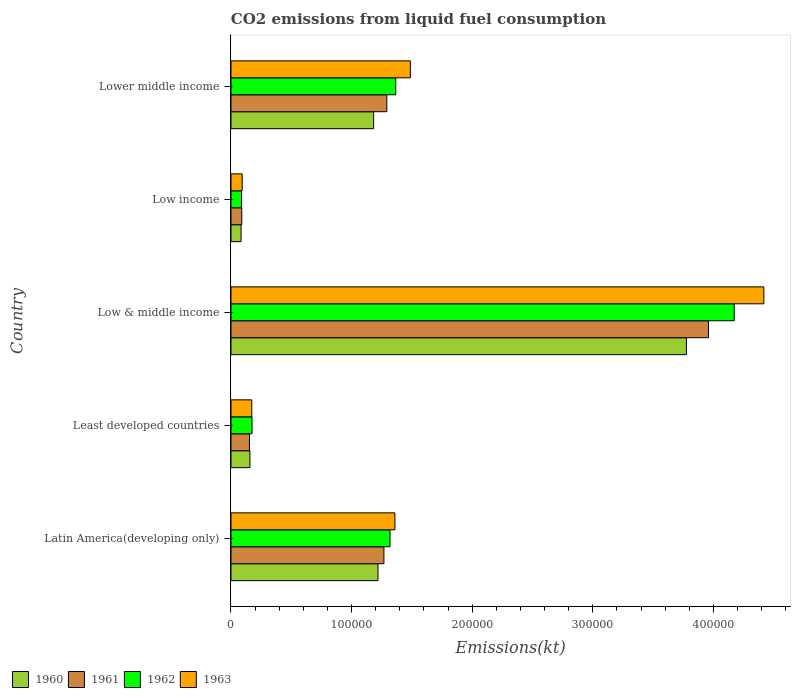How many different coloured bars are there?
Ensure brevity in your answer.  4. How many groups of bars are there?
Give a very brief answer. 5. How many bars are there on the 1st tick from the top?
Make the answer very short. 4. What is the label of the 5th group of bars from the top?
Your response must be concise. Latin America(developing only). What is the amount of CO2 emitted in 1960 in Low income?
Offer a terse response. 8381.5. Across all countries, what is the maximum amount of CO2 emitted in 1962?
Provide a succinct answer. 4.17e+05. Across all countries, what is the minimum amount of CO2 emitted in 1962?
Offer a terse response. 8722.53. In which country was the amount of CO2 emitted in 1960 maximum?
Your response must be concise. Low & middle income. In which country was the amount of CO2 emitted in 1963 minimum?
Offer a very short reply. Low income. What is the total amount of CO2 emitted in 1963 in the graph?
Provide a short and direct response. 7.53e+05. What is the difference between the amount of CO2 emitted in 1960 in Least developed countries and that in Lower middle income?
Ensure brevity in your answer.  -1.03e+05. What is the difference between the amount of CO2 emitted in 1962 in Lower middle income and the amount of CO2 emitted in 1963 in Low & middle income?
Offer a terse response. -3.05e+05. What is the average amount of CO2 emitted in 1961 per country?
Ensure brevity in your answer.  1.35e+05. What is the difference between the amount of CO2 emitted in 1963 and amount of CO2 emitted in 1962 in Low income?
Keep it short and to the point. 558.28. In how many countries, is the amount of CO2 emitted in 1962 greater than 180000 kt?
Ensure brevity in your answer.  1. What is the ratio of the amount of CO2 emitted in 1960 in Low income to that in Lower middle income?
Keep it short and to the point. 0.07. Is the amount of CO2 emitted in 1961 in Latin America(developing only) less than that in Lower middle income?
Make the answer very short. Yes. Is the difference between the amount of CO2 emitted in 1963 in Low & middle income and Lower middle income greater than the difference between the amount of CO2 emitted in 1962 in Low & middle income and Lower middle income?
Provide a short and direct response. Yes. What is the difference between the highest and the second highest amount of CO2 emitted in 1963?
Provide a succinct answer. 2.93e+05. What is the difference between the highest and the lowest amount of CO2 emitted in 1961?
Make the answer very short. 3.87e+05. In how many countries, is the amount of CO2 emitted in 1962 greater than the average amount of CO2 emitted in 1962 taken over all countries?
Your answer should be compact. 1. Is it the case that in every country, the sum of the amount of CO2 emitted in 1961 and amount of CO2 emitted in 1963 is greater than the sum of amount of CO2 emitted in 1962 and amount of CO2 emitted in 1960?
Offer a terse response. No. What does the 1st bar from the bottom in Lower middle income represents?
Give a very brief answer. 1960. Is it the case that in every country, the sum of the amount of CO2 emitted in 1961 and amount of CO2 emitted in 1962 is greater than the amount of CO2 emitted in 1963?
Provide a short and direct response. Yes. Are all the bars in the graph horizontal?
Your answer should be compact. Yes. Does the graph contain any zero values?
Make the answer very short. No. Does the graph contain grids?
Ensure brevity in your answer.  No. How are the legend labels stacked?
Provide a succinct answer. Horizontal. What is the title of the graph?
Your response must be concise. CO2 emissions from liquid fuel consumption. Does "1972" appear as one of the legend labels in the graph?
Keep it short and to the point. No. What is the label or title of the X-axis?
Give a very brief answer. Emissions(kt). What is the Emissions(kt) of 1960 in Latin America(developing only)?
Provide a short and direct response. 1.22e+05. What is the Emissions(kt) of 1961 in Latin America(developing only)?
Offer a very short reply. 1.27e+05. What is the Emissions(kt) of 1962 in Latin America(developing only)?
Ensure brevity in your answer.  1.32e+05. What is the Emissions(kt) in 1963 in Latin America(developing only)?
Your answer should be very brief. 1.36e+05. What is the Emissions(kt) of 1960 in Least developed countries?
Your response must be concise. 1.57e+04. What is the Emissions(kt) in 1961 in Least developed countries?
Keep it short and to the point. 1.53e+04. What is the Emissions(kt) in 1962 in Least developed countries?
Offer a terse response. 1.75e+04. What is the Emissions(kt) in 1963 in Least developed countries?
Give a very brief answer. 1.73e+04. What is the Emissions(kt) of 1960 in Low & middle income?
Offer a terse response. 3.78e+05. What is the Emissions(kt) of 1961 in Low & middle income?
Keep it short and to the point. 3.96e+05. What is the Emissions(kt) of 1962 in Low & middle income?
Keep it short and to the point. 4.17e+05. What is the Emissions(kt) in 1963 in Low & middle income?
Offer a terse response. 4.42e+05. What is the Emissions(kt) in 1960 in Low income?
Provide a short and direct response. 8381.5. What is the Emissions(kt) of 1961 in Low income?
Offer a terse response. 8977.1. What is the Emissions(kt) in 1962 in Low income?
Your answer should be very brief. 8722.53. What is the Emissions(kt) of 1963 in Low income?
Offer a very short reply. 9280.81. What is the Emissions(kt) in 1960 in Lower middle income?
Provide a short and direct response. 1.18e+05. What is the Emissions(kt) of 1961 in Lower middle income?
Your answer should be compact. 1.29e+05. What is the Emissions(kt) in 1962 in Lower middle income?
Your answer should be very brief. 1.37e+05. What is the Emissions(kt) of 1963 in Lower middle income?
Provide a succinct answer. 1.49e+05. Across all countries, what is the maximum Emissions(kt) of 1960?
Offer a very short reply. 3.78e+05. Across all countries, what is the maximum Emissions(kt) of 1961?
Provide a short and direct response. 3.96e+05. Across all countries, what is the maximum Emissions(kt) of 1962?
Make the answer very short. 4.17e+05. Across all countries, what is the maximum Emissions(kt) of 1963?
Give a very brief answer. 4.42e+05. Across all countries, what is the minimum Emissions(kt) of 1960?
Provide a short and direct response. 8381.5. Across all countries, what is the minimum Emissions(kt) in 1961?
Offer a terse response. 8977.1. Across all countries, what is the minimum Emissions(kt) of 1962?
Make the answer very short. 8722.53. Across all countries, what is the minimum Emissions(kt) of 1963?
Ensure brevity in your answer.  9280.81. What is the total Emissions(kt) of 1960 in the graph?
Give a very brief answer. 6.42e+05. What is the total Emissions(kt) of 1961 in the graph?
Offer a terse response. 6.76e+05. What is the total Emissions(kt) of 1962 in the graph?
Provide a succinct answer. 7.12e+05. What is the total Emissions(kt) in 1963 in the graph?
Your answer should be very brief. 7.53e+05. What is the difference between the Emissions(kt) in 1960 in Latin America(developing only) and that in Least developed countries?
Your answer should be very brief. 1.06e+05. What is the difference between the Emissions(kt) of 1961 in Latin America(developing only) and that in Least developed countries?
Ensure brevity in your answer.  1.11e+05. What is the difference between the Emissions(kt) in 1962 in Latin America(developing only) and that in Least developed countries?
Offer a very short reply. 1.14e+05. What is the difference between the Emissions(kt) of 1963 in Latin America(developing only) and that in Least developed countries?
Provide a succinct answer. 1.19e+05. What is the difference between the Emissions(kt) in 1960 in Latin America(developing only) and that in Low & middle income?
Your response must be concise. -2.56e+05. What is the difference between the Emissions(kt) of 1961 in Latin America(developing only) and that in Low & middle income?
Keep it short and to the point. -2.69e+05. What is the difference between the Emissions(kt) of 1962 in Latin America(developing only) and that in Low & middle income?
Offer a very short reply. -2.85e+05. What is the difference between the Emissions(kt) of 1963 in Latin America(developing only) and that in Low & middle income?
Ensure brevity in your answer.  -3.06e+05. What is the difference between the Emissions(kt) in 1960 in Latin America(developing only) and that in Low income?
Offer a terse response. 1.14e+05. What is the difference between the Emissions(kt) of 1961 in Latin America(developing only) and that in Low income?
Keep it short and to the point. 1.18e+05. What is the difference between the Emissions(kt) of 1962 in Latin America(developing only) and that in Low income?
Make the answer very short. 1.23e+05. What is the difference between the Emissions(kt) in 1963 in Latin America(developing only) and that in Low income?
Offer a very short reply. 1.27e+05. What is the difference between the Emissions(kt) of 1960 in Latin America(developing only) and that in Lower middle income?
Ensure brevity in your answer.  3597.92. What is the difference between the Emissions(kt) in 1961 in Latin America(developing only) and that in Lower middle income?
Your answer should be compact. -2399.93. What is the difference between the Emissions(kt) of 1962 in Latin America(developing only) and that in Lower middle income?
Give a very brief answer. -4739.67. What is the difference between the Emissions(kt) of 1963 in Latin America(developing only) and that in Lower middle income?
Keep it short and to the point. -1.28e+04. What is the difference between the Emissions(kt) in 1960 in Least developed countries and that in Low & middle income?
Offer a terse response. -3.62e+05. What is the difference between the Emissions(kt) in 1961 in Least developed countries and that in Low & middle income?
Your answer should be very brief. -3.81e+05. What is the difference between the Emissions(kt) of 1962 in Least developed countries and that in Low & middle income?
Offer a very short reply. -4.00e+05. What is the difference between the Emissions(kt) of 1963 in Least developed countries and that in Low & middle income?
Ensure brevity in your answer.  -4.25e+05. What is the difference between the Emissions(kt) of 1960 in Least developed countries and that in Low income?
Your answer should be very brief. 7358.18. What is the difference between the Emissions(kt) of 1961 in Least developed countries and that in Low income?
Offer a terse response. 6355.39. What is the difference between the Emissions(kt) in 1962 in Least developed countries and that in Low income?
Keep it short and to the point. 8741.59. What is the difference between the Emissions(kt) in 1963 in Least developed countries and that in Low income?
Your response must be concise. 7986.77. What is the difference between the Emissions(kt) in 1960 in Least developed countries and that in Lower middle income?
Ensure brevity in your answer.  -1.03e+05. What is the difference between the Emissions(kt) of 1961 in Least developed countries and that in Lower middle income?
Give a very brief answer. -1.14e+05. What is the difference between the Emissions(kt) of 1962 in Least developed countries and that in Lower middle income?
Your answer should be very brief. -1.19e+05. What is the difference between the Emissions(kt) of 1963 in Least developed countries and that in Lower middle income?
Offer a terse response. -1.31e+05. What is the difference between the Emissions(kt) of 1960 in Low & middle income and that in Low income?
Provide a short and direct response. 3.69e+05. What is the difference between the Emissions(kt) in 1961 in Low & middle income and that in Low income?
Give a very brief answer. 3.87e+05. What is the difference between the Emissions(kt) of 1962 in Low & middle income and that in Low income?
Offer a terse response. 4.09e+05. What is the difference between the Emissions(kt) of 1963 in Low & middle income and that in Low income?
Give a very brief answer. 4.33e+05. What is the difference between the Emissions(kt) in 1960 in Low & middle income and that in Lower middle income?
Provide a short and direct response. 2.59e+05. What is the difference between the Emissions(kt) of 1961 in Low & middle income and that in Lower middle income?
Provide a succinct answer. 2.67e+05. What is the difference between the Emissions(kt) in 1962 in Low & middle income and that in Lower middle income?
Provide a succinct answer. 2.81e+05. What is the difference between the Emissions(kt) in 1963 in Low & middle income and that in Lower middle income?
Provide a short and direct response. 2.93e+05. What is the difference between the Emissions(kt) in 1960 in Low income and that in Lower middle income?
Keep it short and to the point. -1.10e+05. What is the difference between the Emissions(kt) in 1961 in Low income and that in Lower middle income?
Your answer should be very brief. -1.20e+05. What is the difference between the Emissions(kt) of 1962 in Low income and that in Lower middle income?
Provide a short and direct response. -1.28e+05. What is the difference between the Emissions(kt) of 1963 in Low income and that in Lower middle income?
Keep it short and to the point. -1.39e+05. What is the difference between the Emissions(kt) of 1960 in Latin America(developing only) and the Emissions(kt) of 1961 in Least developed countries?
Provide a succinct answer. 1.07e+05. What is the difference between the Emissions(kt) of 1960 in Latin America(developing only) and the Emissions(kt) of 1962 in Least developed countries?
Ensure brevity in your answer.  1.04e+05. What is the difference between the Emissions(kt) in 1960 in Latin America(developing only) and the Emissions(kt) in 1963 in Least developed countries?
Your answer should be compact. 1.05e+05. What is the difference between the Emissions(kt) of 1961 in Latin America(developing only) and the Emissions(kt) of 1962 in Least developed countries?
Your answer should be very brief. 1.09e+05. What is the difference between the Emissions(kt) in 1961 in Latin America(developing only) and the Emissions(kt) in 1963 in Least developed countries?
Make the answer very short. 1.10e+05. What is the difference between the Emissions(kt) in 1962 in Latin America(developing only) and the Emissions(kt) in 1963 in Least developed countries?
Offer a very short reply. 1.15e+05. What is the difference between the Emissions(kt) in 1960 in Latin America(developing only) and the Emissions(kt) in 1961 in Low & middle income?
Offer a terse response. -2.74e+05. What is the difference between the Emissions(kt) in 1960 in Latin America(developing only) and the Emissions(kt) in 1962 in Low & middle income?
Provide a succinct answer. -2.95e+05. What is the difference between the Emissions(kt) in 1960 in Latin America(developing only) and the Emissions(kt) in 1963 in Low & middle income?
Make the answer very short. -3.20e+05. What is the difference between the Emissions(kt) of 1961 in Latin America(developing only) and the Emissions(kt) of 1962 in Low & middle income?
Offer a very short reply. -2.90e+05. What is the difference between the Emissions(kt) of 1961 in Latin America(developing only) and the Emissions(kt) of 1963 in Low & middle income?
Your answer should be very brief. -3.15e+05. What is the difference between the Emissions(kt) of 1962 in Latin America(developing only) and the Emissions(kt) of 1963 in Low & middle income?
Make the answer very short. -3.10e+05. What is the difference between the Emissions(kt) in 1960 in Latin America(developing only) and the Emissions(kt) in 1961 in Low income?
Make the answer very short. 1.13e+05. What is the difference between the Emissions(kt) in 1960 in Latin America(developing only) and the Emissions(kt) in 1962 in Low income?
Your answer should be very brief. 1.13e+05. What is the difference between the Emissions(kt) of 1960 in Latin America(developing only) and the Emissions(kt) of 1963 in Low income?
Offer a very short reply. 1.13e+05. What is the difference between the Emissions(kt) in 1961 in Latin America(developing only) and the Emissions(kt) in 1962 in Low income?
Your answer should be compact. 1.18e+05. What is the difference between the Emissions(kt) of 1961 in Latin America(developing only) and the Emissions(kt) of 1963 in Low income?
Offer a very short reply. 1.18e+05. What is the difference between the Emissions(kt) in 1962 in Latin America(developing only) and the Emissions(kt) in 1963 in Low income?
Provide a succinct answer. 1.23e+05. What is the difference between the Emissions(kt) of 1960 in Latin America(developing only) and the Emissions(kt) of 1961 in Lower middle income?
Make the answer very short. -7321.05. What is the difference between the Emissions(kt) in 1960 in Latin America(developing only) and the Emissions(kt) in 1962 in Lower middle income?
Offer a terse response. -1.47e+04. What is the difference between the Emissions(kt) of 1960 in Latin America(developing only) and the Emissions(kt) of 1963 in Lower middle income?
Offer a very short reply. -2.68e+04. What is the difference between the Emissions(kt) in 1961 in Latin America(developing only) and the Emissions(kt) in 1962 in Lower middle income?
Your answer should be very brief. -9800.13. What is the difference between the Emissions(kt) in 1961 in Latin America(developing only) and the Emissions(kt) in 1963 in Lower middle income?
Provide a short and direct response. -2.19e+04. What is the difference between the Emissions(kt) of 1962 in Latin America(developing only) and the Emissions(kt) of 1963 in Lower middle income?
Offer a very short reply. -1.69e+04. What is the difference between the Emissions(kt) in 1960 in Least developed countries and the Emissions(kt) in 1961 in Low & middle income?
Make the answer very short. -3.80e+05. What is the difference between the Emissions(kt) of 1960 in Least developed countries and the Emissions(kt) of 1962 in Low & middle income?
Offer a terse response. -4.02e+05. What is the difference between the Emissions(kt) in 1960 in Least developed countries and the Emissions(kt) in 1963 in Low & middle income?
Provide a succinct answer. -4.26e+05. What is the difference between the Emissions(kt) of 1961 in Least developed countries and the Emissions(kt) of 1962 in Low & middle income?
Offer a terse response. -4.02e+05. What is the difference between the Emissions(kt) of 1961 in Least developed countries and the Emissions(kt) of 1963 in Low & middle income?
Offer a very short reply. -4.27e+05. What is the difference between the Emissions(kt) in 1962 in Least developed countries and the Emissions(kt) in 1963 in Low & middle income?
Keep it short and to the point. -4.24e+05. What is the difference between the Emissions(kt) in 1960 in Least developed countries and the Emissions(kt) in 1961 in Low income?
Make the answer very short. 6762.59. What is the difference between the Emissions(kt) in 1960 in Least developed countries and the Emissions(kt) in 1962 in Low income?
Keep it short and to the point. 7017.15. What is the difference between the Emissions(kt) in 1960 in Least developed countries and the Emissions(kt) in 1963 in Low income?
Offer a terse response. 6458.87. What is the difference between the Emissions(kt) of 1961 in Least developed countries and the Emissions(kt) of 1962 in Low income?
Keep it short and to the point. 6609.95. What is the difference between the Emissions(kt) in 1961 in Least developed countries and the Emissions(kt) in 1963 in Low income?
Your response must be concise. 6051.67. What is the difference between the Emissions(kt) of 1962 in Least developed countries and the Emissions(kt) of 1963 in Low income?
Provide a short and direct response. 8183.31. What is the difference between the Emissions(kt) of 1960 in Least developed countries and the Emissions(kt) of 1961 in Lower middle income?
Provide a short and direct response. -1.13e+05. What is the difference between the Emissions(kt) in 1960 in Least developed countries and the Emissions(kt) in 1962 in Lower middle income?
Provide a succinct answer. -1.21e+05. What is the difference between the Emissions(kt) of 1960 in Least developed countries and the Emissions(kt) of 1963 in Lower middle income?
Ensure brevity in your answer.  -1.33e+05. What is the difference between the Emissions(kt) of 1961 in Least developed countries and the Emissions(kt) of 1962 in Lower middle income?
Your answer should be compact. -1.21e+05. What is the difference between the Emissions(kt) in 1961 in Least developed countries and the Emissions(kt) in 1963 in Lower middle income?
Offer a terse response. -1.33e+05. What is the difference between the Emissions(kt) in 1962 in Least developed countries and the Emissions(kt) in 1963 in Lower middle income?
Offer a terse response. -1.31e+05. What is the difference between the Emissions(kt) in 1960 in Low & middle income and the Emissions(kt) in 1961 in Low income?
Provide a short and direct response. 3.69e+05. What is the difference between the Emissions(kt) in 1960 in Low & middle income and the Emissions(kt) in 1962 in Low income?
Provide a short and direct response. 3.69e+05. What is the difference between the Emissions(kt) in 1960 in Low & middle income and the Emissions(kt) in 1963 in Low income?
Ensure brevity in your answer.  3.68e+05. What is the difference between the Emissions(kt) in 1961 in Low & middle income and the Emissions(kt) in 1962 in Low income?
Ensure brevity in your answer.  3.87e+05. What is the difference between the Emissions(kt) in 1961 in Low & middle income and the Emissions(kt) in 1963 in Low income?
Offer a terse response. 3.87e+05. What is the difference between the Emissions(kt) in 1962 in Low & middle income and the Emissions(kt) in 1963 in Low income?
Provide a short and direct response. 4.08e+05. What is the difference between the Emissions(kt) in 1960 in Low & middle income and the Emissions(kt) in 1961 in Lower middle income?
Give a very brief answer. 2.48e+05. What is the difference between the Emissions(kt) of 1960 in Low & middle income and the Emissions(kt) of 1962 in Lower middle income?
Provide a succinct answer. 2.41e+05. What is the difference between the Emissions(kt) of 1960 in Low & middle income and the Emissions(kt) of 1963 in Lower middle income?
Offer a very short reply. 2.29e+05. What is the difference between the Emissions(kt) of 1961 in Low & middle income and the Emissions(kt) of 1962 in Lower middle income?
Ensure brevity in your answer.  2.59e+05. What is the difference between the Emissions(kt) of 1961 in Low & middle income and the Emissions(kt) of 1963 in Lower middle income?
Your response must be concise. 2.47e+05. What is the difference between the Emissions(kt) in 1962 in Low & middle income and the Emissions(kt) in 1963 in Lower middle income?
Provide a succinct answer. 2.69e+05. What is the difference between the Emissions(kt) in 1960 in Low income and the Emissions(kt) in 1961 in Lower middle income?
Ensure brevity in your answer.  -1.21e+05. What is the difference between the Emissions(kt) in 1960 in Low income and the Emissions(kt) in 1962 in Lower middle income?
Your answer should be compact. -1.28e+05. What is the difference between the Emissions(kt) of 1960 in Low income and the Emissions(kt) of 1963 in Lower middle income?
Offer a terse response. -1.40e+05. What is the difference between the Emissions(kt) of 1961 in Low income and the Emissions(kt) of 1962 in Lower middle income?
Your answer should be compact. -1.28e+05. What is the difference between the Emissions(kt) in 1961 in Low income and the Emissions(kt) in 1963 in Lower middle income?
Provide a short and direct response. -1.40e+05. What is the difference between the Emissions(kt) of 1962 in Low income and the Emissions(kt) of 1963 in Lower middle income?
Your answer should be compact. -1.40e+05. What is the average Emissions(kt) of 1960 per country?
Provide a succinct answer. 1.28e+05. What is the average Emissions(kt) of 1961 per country?
Keep it short and to the point. 1.35e+05. What is the average Emissions(kt) in 1962 per country?
Offer a terse response. 1.42e+05. What is the average Emissions(kt) in 1963 per country?
Keep it short and to the point. 1.51e+05. What is the difference between the Emissions(kt) of 1960 and Emissions(kt) of 1961 in Latin America(developing only)?
Offer a terse response. -4921.11. What is the difference between the Emissions(kt) of 1960 and Emissions(kt) of 1962 in Latin America(developing only)?
Your answer should be very brief. -9981.57. What is the difference between the Emissions(kt) of 1960 and Emissions(kt) of 1963 in Latin America(developing only)?
Ensure brevity in your answer.  -1.40e+04. What is the difference between the Emissions(kt) in 1961 and Emissions(kt) in 1962 in Latin America(developing only)?
Offer a terse response. -5060.46. What is the difference between the Emissions(kt) of 1961 and Emissions(kt) of 1963 in Latin America(developing only)?
Your answer should be very brief. -9119.83. What is the difference between the Emissions(kt) of 1962 and Emissions(kt) of 1963 in Latin America(developing only)?
Offer a very short reply. -4059.37. What is the difference between the Emissions(kt) in 1960 and Emissions(kt) in 1961 in Least developed countries?
Your answer should be compact. 407.2. What is the difference between the Emissions(kt) of 1960 and Emissions(kt) of 1962 in Least developed countries?
Provide a succinct answer. -1724.44. What is the difference between the Emissions(kt) of 1960 and Emissions(kt) of 1963 in Least developed countries?
Keep it short and to the point. -1527.9. What is the difference between the Emissions(kt) in 1961 and Emissions(kt) in 1962 in Least developed countries?
Ensure brevity in your answer.  -2131.64. What is the difference between the Emissions(kt) in 1961 and Emissions(kt) in 1963 in Least developed countries?
Give a very brief answer. -1935.1. What is the difference between the Emissions(kt) of 1962 and Emissions(kt) of 1963 in Least developed countries?
Offer a terse response. 196.54. What is the difference between the Emissions(kt) in 1960 and Emissions(kt) in 1961 in Low & middle income?
Offer a terse response. -1.83e+04. What is the difference between the Emissions(kt) in 1960 and Emissions(kt) in 1962 in Low & middle income?
Offer a terse response. -3.96e+04. What is the difference between the Emissions(kt) of 1960 and Emissions(kt) of 1963 in Low & middle income?
Provide a succinct answer. -6.42e+04. What is the difference between the Emissions(kt) in 1961 and Emissions(kt) in 1962 in Low & middle income?
Ensure brevity in your answer.  -2.14e+04. What is the difference between the Emissions(kt) in 1961 and Emissions(kt) in 1963 in Low & middle income?
Keep it short and to the point. -4.59e+04. What is the difference between the Emissions(kt) of 1962 and Emissions(kt) of 1963 in Low & middle income?
Your response must be concise. -2.46e+04. What is the difference between the Emissions(kt) in 1960 and Emissions(kt) in 1961 in Low income?
Make the answer very short. -595.59. What is the difference between the Emissions(kt) of 1960 and Emissions(kt) of 1962 in Low income?
Your answer should be compact. -341.02. What is the difference between the Emissions(kt) in 1960 and Emissions(kt) in 1963 in Low income?
Your answer should be compact. -899.3. What is the difference between the Emissions(kt) of 1961 and Emissions(kt) of 1962 in Low income?
Keep it short and to the point. 254.57. What is the difference between the Emissions(kt) of 1961 and Emissions(kt) of 1963 in Low income?
Provide a succinct answer. -303.71. What is the difference between the Emissions(kt) in 1962 and Emissions(kt) in 1963 in Low income?
Provide a short and direct response. -558.28. What is the difference between the Emissions(kt) in 1960 and Emissions(kt) in 1961 in Lower middle income?
Your answer should be compact. -1.09e+04. What is the difference between the Emissions(kt) in 1960 and Emissions(kt) in 1962 in Lower middle income?
Your answer should be very brief. -1.83e+04. What is the difference between the Emissions(kt) of 1960 and Emissions(kt) of 1963 in Lower middle income?
Provide a short and direct response. -3.04e+04. What is the difference between the Emissions(kt) of 1961 and Emissions(kt) of 1962 in Lower middle income?
Offer a terse response. -7400.19. What is the difference between the Emissions(kt) in 1961 and Emissions(kt) in 1963 in Lower middle income?
Offer a terse response. -1.95e+04. What is the difference between the Emissions(kt) of 1962 and Emissions(kt) of 1963 in Lower middle income?
Your answer should be compact. -1.21e+04. What is the ratio of the Emissions(kt) in 1960 in Latin America(developing only) to that in Least developed countries?
Make the answer very short. 7.74. What is the ratio of the Emissions(kt) of 1961 in Latin America(developing only) to that in Least developed countries?
Provide a succinct answer. 8.27. What is the ratio of the Emissions(kt) in 1962 in Latin America(developing only) to that in Least developed countries?
Ensure brevity in your answer.  7.55. What is the ratio of the Emissions(kt) in 1963 in Latin America(developing only) to that in Least developed countries?
Make the answer very short. 7.87. What is the ratio of the Emissions(kt) of 1960 in Latin America(developing only) to that in Low & middle income?
Offer a very short reply. 0.32. What is the ratio of the Emissions(kt) of 1961 in Latin America(developing only) to that in Low & middle income?
Provide a succinct answer. 0.32. What is the ratio of the Emissions(kt) of 1962 in Latin America(developing only) to that in Low & middle income?
Offer a very short reply. 0.32. What is the ratio of the Emissions(kt) in 1963 in Latin America(developing only) to that in Low & middle income?
Provide a succinct answer. 0.31. What is the ratio of the Emissions(kt) in 1960 in Latin America(developing only) to that in Low income?
Offer a very short reply. 14.54. What is the ratio of the Emissions(kt) of 1961 in Latin America(developing only) to that in Low income?
Ensure brevity in your answer.  14.13. What is the ratio of the Emissions(kt) in 1962 in Latin America(developing only) to that in Low income?
Make the answer very short. 15.12. What is the ratio of the Emissions(kt) of 1963 in Latin America(developing only) to that in Low income?
Provide a short and direct response. 14.65. What is the ratio of the Emissions(kt) in 1960 in Latin America(developing only) to that in Lower middle income?
Provide a short and direct response. 1.03. What is the ratio of the Emissions(kt) of 1961 in Latin America(developing only) to that in Lower middle income?
Give a very brief answer. 0.98. What is the ratio of the Emissions(kt) of 1962 in Latin America(developing only) to that in Lower middle income?
Your answer should be very brief. 0.97. What is the ratio of the Emissions(kt) of 1963 in Latin America(developing only) to that in Lower middle income?
Your response must be concise. 0.91. What is the ratio of the Emissions(kt) of 1960 in Least developed countries to that in Low & middle income?
Provide a succinct answer. 0.04. What is the ratio of the Emissions(kt) of 1961 in Least developed countries to that in Low & middle income?
Provide a succinct answer. 0.04. What is the ratio of the Emissions(kt) in 1962 in Least developed countries to that in Low & middle income?
Offer a terse response. 0.04. What is the ratio of the Emissions(kt) in 1963 in Least developed countries to that in Low & middle income?
Your answer should be very brief. 0.04. What is the ratio of the Emissions(kt) of 1960 in Least developed countries to that in Low income?
Keep it short and to the point. 1.88. What is the ratio of the Emissions(kt) in 1961 in Least developed countries to that in Low income?
Ensure brevity in your answer.  1.71. What is the ratio of the Emissions(kt) in 1962 in Least developed countries to that in Low income?
Ensure brevity in your answer.  2. What is the ratio of the Emissions(kt) of 1963 in Least developed countries to that in Low income?
Your answer should be very brief. 1.86. What is the ratio of the Emissions(kt) of 1960 in Least developed countries to that in Lower middle income?
Provide a succinct answer. 0.13. What is the ratio of the Emissions(kt) in 1961 in Least developed countries to that in Lower middle income?
Your answer should be compact. 0.12. What is the ratio of the Emissions(kt) in 1962 in Least developed countries to that in Lower middle income?
Provide a succinct answer. 0.13. What is the ratio of the Emissions(kt) in 1963 in Least developed countries to that in Lower middle income?
Give a very brief answer. 0.12. What is the ratio of the Emissions(kt) of 1960 in Low & middle income to that in Low income?
Ensure brevity in your answer.  45.06. What is the ratio of the Emissions(kt) in 1961 in Low & middle income to that in Low income?
Keep it short and to the point. 44.1. What is the ratio of the Emissions(kt) in 1962 in Low & middle income to that in Low income?
Your answer should be compact. 47.84. What is the ratio of the Emissions(kt) of 1963 in Low & middle income to that in Low income?
Provide a short and direct response. 47.61. What is the ratio of the Emissions(kt) in 1960 in Low & middle income to that in Lower middle income?
Give a very brief answer. 3.19. What is the ratio of the Emissions(kt) in 1961 in Low & middle income to that in Lower middle income?
Offer a very short reply. 3.06. What is the ratio of the Emissions(kt) in 1962 in Low & middle income to that in Lower middle income?
Make the answer very short. 3.05. What is the ratio of the Emissions(kt) in 1963 in Low & middle income to that in Lower middle income?
Offer a very short reply. 2.97. What is the ratio of the Emissions(kt) of 1960 in Low income to that in Lower middle income?
Ensure brevity in your answer.  0.07. What is the ratio of the Emissions(kt) of 1961 in Low income to that in Lower middle income?
Provide a short and direct response. 0.07. What is the ratio of the Emissions(kt) in 1962 in Low income to that in Lower middle income?
Offer a very short reply. 0.06. What is the ratio of the Emissions(kt) in 1963 in Low income to that in Lower middle income?
Your response must be concise. 0.06. What is the difference between the highest and the second highest Emissions(kt) of 1960?
Offer a very short reply. 2.56e+05. What is the difference between the highest and the second highest Emissions(kt) of 1961?
Give a very brief answer. 2.67e+05. What is the difference between the highest and the second highest Emissions(kt) in 1962?
Your answer should be compact. 2.81e+05. What is the difference between the highest and the second highest Emissions(kt) in 1963?
Your answer should be very brief. 2.93e+05. What is the difference between the highest and the lowest Emissions(kt) in 1960?
Ensure brevity in your answer.  3.69e+05. What is the difference between the highest and the lowest Emissions(kt) of 1961?
Your answer should be very brief. 3.87e+05. What is the difference between the highest and the lowest Emissions(kt) in 1962?
Offer a terse response. 4.09e+05. What is the difference between the highest and the lowest Emissions(kt) of 1963?
Your answer should be compact. 4.33e+05. 